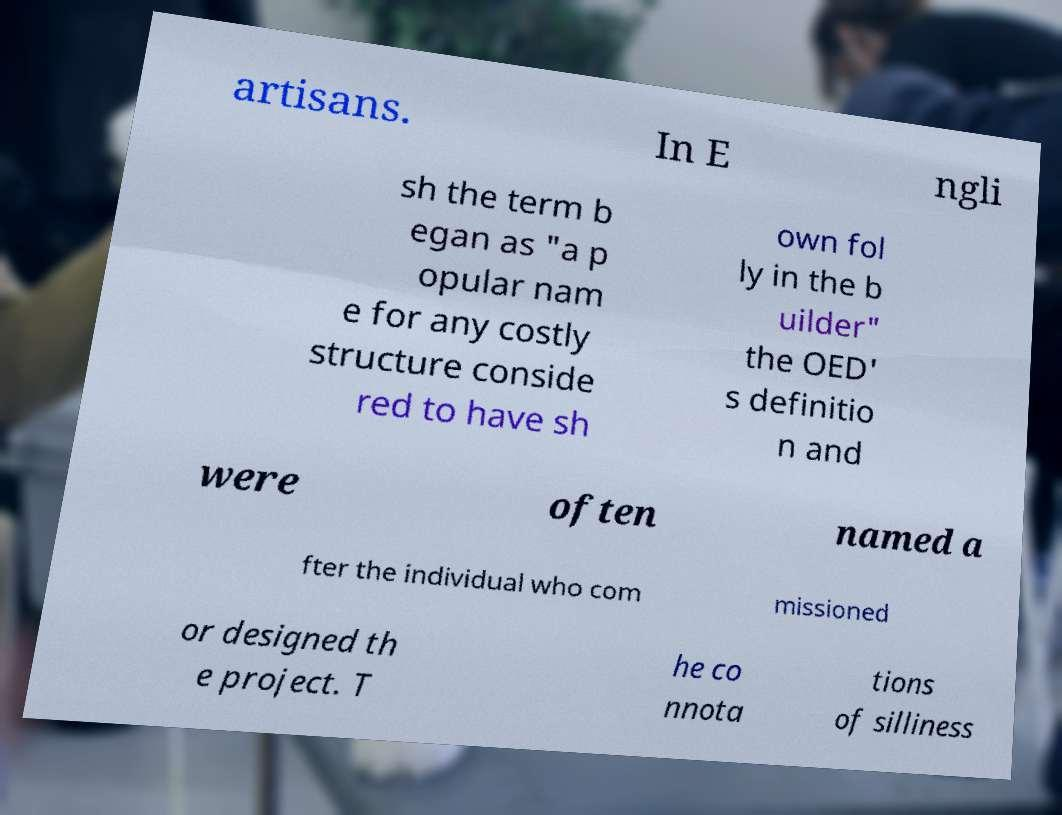Please identify and transcribe the text found in this image. artisans. In E ngli sh the term b egan as "a p opular nam e for any costly structure conside red to have sh own fol ly in the b uilder" the OED' s definitio n and were often named a fter the individual who com missioned or designed th e project. T he co nnota tions of silliness 